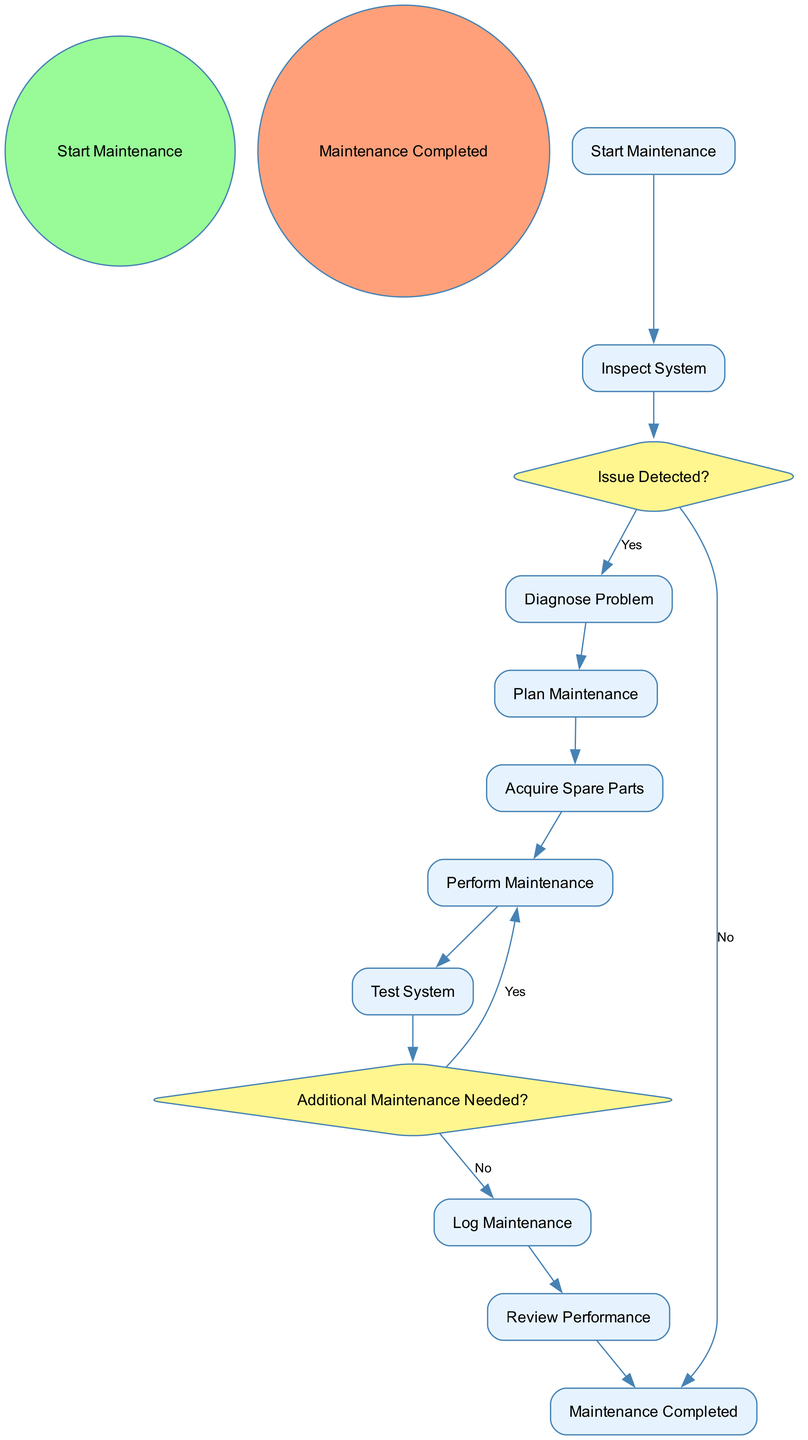What is the starting event in the diagram? The starting event is labeled as "Start Maintenance" which is the first action required to initiate the maintenance protocol.
Answer: Start Maintenance What activity follows the "Inspect System" node? After "Inspect System", the next decision node is "Issue Detected?", indicating the flow goes from the inspection to assessing if issues were found.
Answer: Issue Detected? How many activities are listed in the diagram? The diagram includes eight activities which outline the steps in the maintenance protocol for marine propulsion systems.
Answer: Eight What happens if an issue is detected during the inspection? If the answer to "Issue Detected?" is Yes, the flow moves to "Diagnose Problem", indicating that the diagnosis of the problem is the next step if issues are identified.
Answer: Diagnose Problem What is the final event in the process? The final event in the maintenance process is labeled as "Maintenance Completed", marking the end of the maintenance protocol after all steps have been followed.
Answer: Maintenance Completed If additional maintenance is needed after testing, what activity is performed next? If further maintenance is identified as needed, the process returns to "Perform Maintenance" indicating that new maintenance tasks must be executed.
Answer: Perform Maintenance Which decision node determines if further maintenance is necessary? The decision node that assesses the need for additional maintenance is labeled as "Additional Maintenance Needed?". It follows the "Test System" activity.
Answer: Additional Maintenance Needed? How many decision nodes are present in the diagram? There are two decision nodes in the diagram, which are "Issue Detected?" and "Additional Maintenance Needed?".
Answer: Two What comes after the "Log Maintenance" activity? After the "Log Maintenance" activity, the next step in the process is "Review Performance", allowing for evaluation of the system post-maintenance.
Answer: Review Performance 